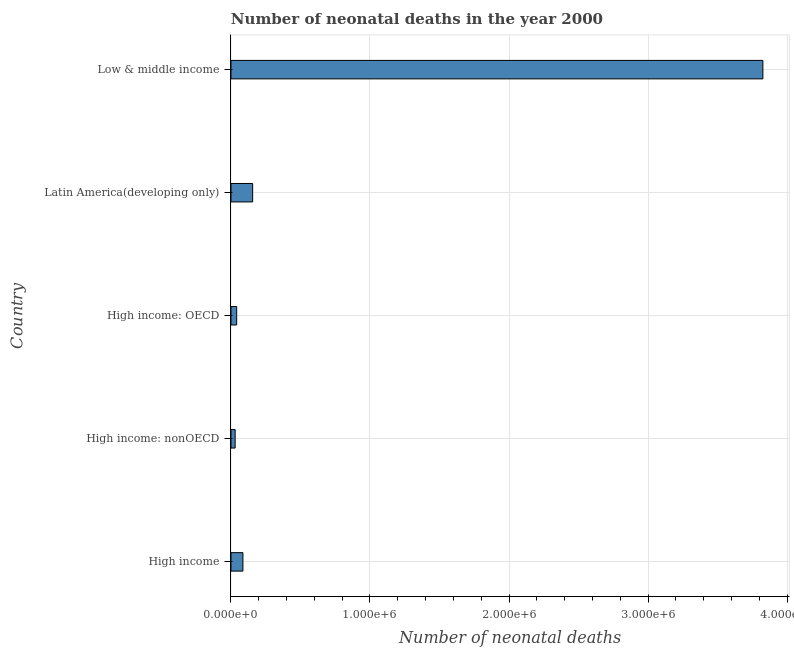Does the graph contain grids?
Offer a terse response. Yes. What is the title of the graph?
Your answer should be very brief. Number of neonatal deaths in the year 2000. What is the label or title of the X-axis?
Keep it short and to the point. Number of neonatal deaths. What is the label or title of the Y-axis?
Provide a short and direct response. Country. What is the number of neonatal deaths in High income: OECD?
Ensure brevity in your answer.  4.10e+04. Across all countries, what is the maximum number of neonatal deaths?
Your answer should be compact. 3.83e+06. Across all countries, what is the minimum number of neonatal deaths?
Make the answer very short. 3.00e+04. In which country was the number of neonatal deaths maximum?
Give a very brief answer. Low & middle income. In which country was the number of neonatal deaths minimum?
Keep it short and to the point. High income: nonOECD. What is the sum of the number of neonatal deaths?
Offer a very short reply. 4.14e+06. What is the difference between the number of neonatal deaths in High income: OECD and Low & middle income?
Keep it short and to the point. -3.79e+06. What is the average number of neonatal deaths per country?
Make the answer very short. 8.28e+05. What is the median number of neonatal deaths?
Ensure brevity in your answer.  8.59e+04. In how many countries, is the number of neonatal deaths greater than 800000 ?
Offer a terse response. 1. What is the ratio of the number of neonatal deaths in High income to that in Latin America(developing only)?
Your answer should be compact. 0.55. Is the number of neonatal deaths in High income: nonOECD less than that in Latin America(developing only)?
Give a very brief answer. Yes. What is the difference between the highest and the second highest number of neonatal deaths?
Offer a very short reply. 3.67e+06. What is the difference between the highest and the lowest number of neonatal deaths?
Your answer should be compact. 3.80e+06. How many bars are there?
Provide a short and direct response. 5. How many countries are there in the graph?
Keep it short and to the point. 5. What is the difference between two consecutive major ticks on the X-axis?
Make the answer very short. 1.00e+06. What is the Number of neonatal deaths in High income?
Your answer should be compact. 8.59e+04. What is the Number of neonatal deaths of High income: OECD?
Give a very brief answer. 4.10e+04. What is the Number of neonatal deaths in Latin America(developing only)?
Your answer should be compact. 1.56e+05. What is the Number of neonatal deaths in Low & middle income?
Give a very brief answer. 3.83e+06. What is the difference between the Number of neonatal deaths in High income and High income: nonOECD?
Offer a very short reply. 5.59e+04. What is the difference between the Number of neonatal deaths in High income and High income: OECD?
Give a very brief answer. 4.49e+04. What is the difference between the Number of neonatal deaths in High income and Latin America(developing only)?
Give a very brief answer. -7.01e+04. What is the difference between the Number of neonatal deaths in High income and Low & middle income?
Provide a short and direct response. -3.74e+06. What is the difference between the Number of neonatal deaths in High income: nonOECD and High income: OECD?
Keep it short and to the point. -1.10e+04. What is the difference between the Number of neonatal deaths in High income: nonOECD and Latin America(developing only)?
Keep it short and to the point. -1.26e+05. What is the difference between the Number of neonatal deaths in High income: nonOECD and Low & middle income?
Offer a terse response. -3.80e+06. What is the difference between the Number of neonatal deaths in High income: OECD and Latin America(developing only)?
Give a very brief answer. -1.15e+05. What is the difference between the Number of neonatal deaths in High income: OECD and Low & middle income?
Provide a succinct answer. -3.79e+06. What is the difference between the Number of neonatal deaths in Latin America(developing only) and Low & middle income?
Make the answer very short. -3.67e+06. What is the ratio of the Number of neonatal deaths in High income to that in High income: nonOECD?
Your answer should be very brief. 2.86. What is the ratio of the Number of neonatal deaths in High income to that in High income: OECD?
Provide a short and direct response. 2.1. What is the ratio of the Number of neonatal deaths in High income to that in Latin America(developing only)?
Provide a succinct answer. 0.55. What is the ratio of the Number of neonatal deaths in High income to that in Low & middle income?
Offer a very short reply. 0.02. What is the ratio of the Number of neonatal deaths in High income: nonOECD to that in High income: OECD?
Your answer should be very brief. 0.73. What is the ratio of the Number of neonatal deaths in High income: nonOECD to that in Latin America(developing only)?
Your answer should be very brief. 0.19. What is the ratio of the Number of neonatal deaths in High income: nonOECD to that in Low & middle income?
Make the answer very short. 0.01. What is the ratio of the Number of neonatal deaths in High income: OECD to that in Latin America(developing only)?
Offer a terse response. 0.26. What is the ratio of the Number of neonatal deaths in High income: OECD to that in Low & middle income?
Give a very brief answer. 0.01. What is the ratio of the Number of neonatal deaths in Latin America(developing only) to that in Low & middle income?
Ensure brevity in your answer.  0.04. 